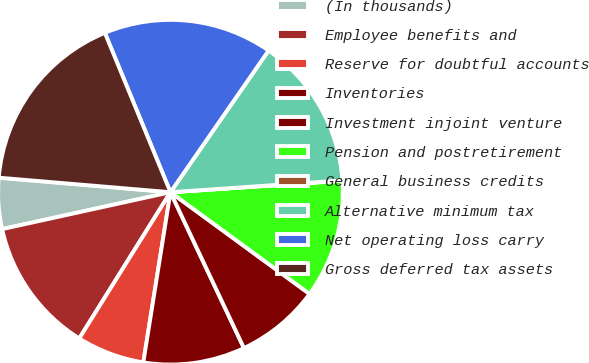<chart> <loc_0><loc_0><loc_500><loc_500><pie_chart><fcel>(In thousands)<fcel>Employee benefits and<fcel>Reserve for doubtful accounts<fcel>Inventories<fcel>Investment injoint venture<fcel>Pension and postretirement<fcel>General business credits<fcel>Alternative minimum tax<fcel>Net operating loss carry<fcel>Gross deferred tax assets<nl><fcel>4.78%<fcel>12.69%<fcel>6.36%<fcel>9.53%<fcel>7.94%<fcel>11.11%<fcel>0.03%<fcel>14.27%<fcel>15.86%<fcel>17.44%<nl></chart> 